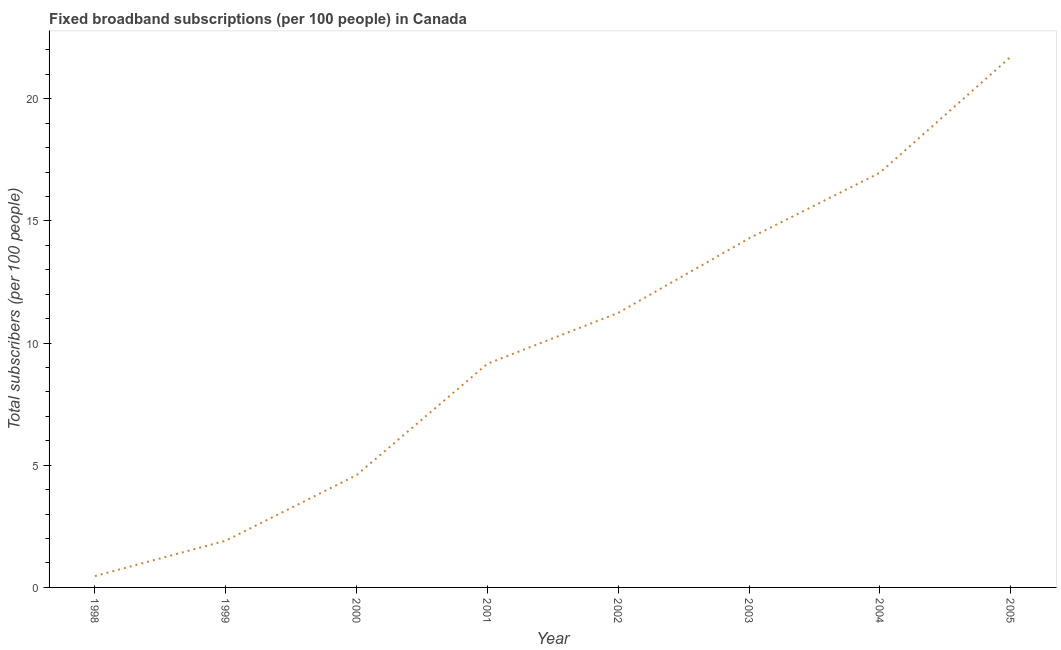What is the total number of fixed broadband subscriptions in 2005?
Offer a terse response. 21.72. Across all years, what is the maximum total number of fixed broadband subscriptions?
Make the answer very short. 21.72. Across all years, what is the minimum total number of fixed broadband subscriptions?
Your answer should be very brief. 0.46. What is the sum of the total number of fixed broadband subscriptions?
Give a very brief answer. 80.33. What is the difference between the total number of fixed broadband subscriptions in 2000 and 2002?
Offer a terse response. -6.64. What is the average total number of fixed broadband subscriptions per year?
Ensure brevity in your answer.  10.04. What is the median total number of fixed broadband subscriptions?
Your response must be concise. 10.19. In how many years, is the total number of fixed broadband subscriptions greater than 3 ?
Provide a short and direct response. 6. Do a majority of the years between 2002 and 2005 (inclusive) have total number of fixed broadband subscriptions greater than 8 ?
Keep it short and to the point. Yes. What is the ratio of the total number of fixed broadband subscriptions in 1998 to that in 2001?
Your answer should be compact. 0.05. Is the total number of fixed broadband subscriptions in 1999 less than that in 2001?
Provide a succinct answer. Yes. What is the difference between the highest and the second highest total number of fixed broadband subscriptions?
Offer a very short reply. 4.75. Is the sum of the total number of fixed broadband subscriptions in 2000 and 2002 greater than the maximum total number of fixed broadband subscriptions across all years?
Your answer should be very brief. No. What is the difference between the highest and the lowest total number of fixed broadband subscriptions?
Ensure brevity in your answer.  21.25. Does the total number of fixed broadband subscriptions monotonically increase over the years?
Provide a succinct answer. Yes. How many lines are there?
Your answer should be compact. 1. How many years are there in the graph?
Offer a terse response. 8. What is the difference between two consecutive major ticks on the Y-axis?
Ensure brevity in your answer.  5. Are the values on the major ticks of Y-axis written in scientific E-notation?
Provide a short and direct response. No. Does the graph contain any zero values?
Keep it short and to the point. No. What is the title of the graph?
Your answer should be very brief. Fixed broadband subscriptions (per 100 people) in Canada. What is the label or title of the X-axis?
Your response must be concise. Year. What is the label or title of the Y-axis?
Make the answer very short. Total subscribers (per 100 people). What is the Total subscribers (per 100 people) of 1998?
Offer a very short reply. 0.46. What is the Total subscribers (per 100 people) of 1999?
Offer a terse response. 1.91. What is the Total subscribers (per 100 people) of 2000?
Ensure brevity in your answer.  4.6. What is the Total subscribers (per 100 people) in 2001?
Give a very brief answer. 9.15. What is the Total subscribers (per 100 people) of 2002?
Offer a very short reply. 11.24. What is the Total subscribers (per 100 people) in 2003?
Your answer should be compact. 14.29. What is the Total subscribers (per 100 people) of 2004?
Make the answer very short. 16.97. What is the Total subscribers (per 100 people) in 2005?
Your response must be concise. 21.72. What is the difference between the Total subscribers (per 100 people) in 1998 and 1999?
Give a very brief answer. -1.45. What is the difference between the Total subscribers (per 100 people) in 1998 and 2000?
Ensure brevity in your answer.  -4.13. What is the difference between the Total subscribers (per 100 people) in 1998 and 2001?
Give a very brief answer. -8.69. What is the difference between the Total subscribers (per 100 people) in 1998 and 2002?
Give a very brief answer. -10.77. What is the difference between the Total subscribers (per 100 people) in 1998 and 2003?
Give a very brief answer. -13.82. What is the difference between the Total subscribers (per 100 people) in 1998 and 2004?
Your answer should be compact. -16.51. What is the difference between the Total subscribers (per 100 people) in 1998 and 2005?
Your response must be concise. -21.25. What is the difference between the Total subscribers (per 100 people) in 1999 and 2000?
Provide a succinct answer. -2.68. What is the difference between the Total subscribers (per 100 people) in 1999 and 2001?
Make the answer very short. -7.24. What is the difference between the Total subscribers (per 100 people) in 1999 and 2002?
Your response must be concise. -9.32. What is the difference between the Total subscribers (per 100 people) in 1999 and 2003?
Offer a terse response. -12.37. What is the difference between the Total subscribers (per 100 people) in 1999 and 2004?
Your answer should be very brief. -15.06. What is the difference between the Total subscribers (per 100 people) in 1999 and 2005?
Offer a very short reply. -19.8. What is the difference between the Total subscribers (per 100 people) in 2000 and 2001?
Give a very brief answer. -4.56. What is the difference between the Total subscribers (per 100 people) in 2000 and 2002?
Offer a very short reply. -6.64. What is the difference between the Total subscribers (per 100 people) in 2000 and 2003?
Offer a very short reply. -9.69. What is the difference between the Total subscribers (per 100 people) in 2000 and 2004?
Your response must be concise. -12.37. What is the difference between the Total subscribers (per 100 people) in 2000 and 2005?
Offer a very short reply. -17.12. What is the difference between the Total subscribers (per 100 people) in 2001 and 2002?
Make the answer very short. -2.08. What is the difference between the Total subscribers (per 100 people) in 2001 and 2003?
Offer a terse response. -5.13. What is the difference between the Total subscribers (per 100 people) in 2001 and 2004?
Give a very brief answer. -7.82. What is the difference between the Total subscribers (per 100 people) in 2001 and 2005?
Offer a terse response. -12.56. What is the difference between the Total subscribers (per 100 people) in 2002 and 2003?
Your response must be concise. -3.05. What is the difference between the Total subscribers (per 100 people) in 2002 and 2004?
Provide a short and direct response. -5.73. What is the difference between the Total subscribers (per 100 people) in 2002 and 2005?
Your response must be concise. -10.48. What is the difference between the Total subscribers (per 100 people) in 2003 and 2004?
Make the answer very short. -2.69. What is the difference between the Total subscribers (per 100 people) in 2003 and 2005?
Provide a succinct answer. -7.43. What is the difference between the Total subscribers (per 100 people) in 2004 and 2005?
Provide a succinct answer. -4.75. What is the ratio of the Total subscribers (per 100 people) in 1998 to that in 1999?
Offer a very short reply. 0.24. What is the ratio of the Total subscribers (per 100 people) in 1998 to that in 2000?
Keep it short and to the point. 0.1. What is the ratio of the Total subscribers (per 100 people) in 1998 to that in 2001?
Provide a succinct answer. 0.05. What is the ratio of the Total subscribers (per 100 people) in 1998 to that in 2002?
Your answer should be very brief. 0.04. What is the ratio of the Total subscribers (per 100 people) in 1998 to that in 2003?
Give a very brief answer. 0.03. What is the ratio of the Total subscribers (per 100 people) in 1998 to that in 2004?
Your response must be concise. 0.03. What is the ratio of the Total subscribers (per 100 people) in 1998 to that in 2005?
Your answer should be very brief. 0.02. What is the ratio of the Total subscribers (per 100 people) in 1999 to that in 2000?
Provide a succinct answer. 0.42. What is the ratio of the Total subscribers (per 100 people) in 1999 to that in 2001?
Make the answer very short. 0.21. What is the ratio of the Total subscribers (per 100 people) in 1999 to that in 2002?
Give a very brief answer. 0.17. What is the ratio of the Total subscribers (per 100 people) in 1999 to that in 2003?
Your answer should be very brief. 0.13. What is the ratio of the Total subscribers (per 100 people) in 1999 to that in 2004?
Provide a short and direct response. 0.11. What is the ratio of the Total subscribers (per 100 people) in 1999 to that in 2005?
Offer a terse response. 0.09. What is the ratio of the Total subscribers (per 100 people) in 2000 to that in 2001?
Offer a very short reply. 0.5. What is the ratio of the Total subscribers (per 100 people) in 2000 to that in 2002?
Provide a succinct answer. 0.41. What is the ratio of the Total subscribers (per 100 people) in 2000 to that in 2003?
Keep it short and to the point. 0.32. What is the ratio of the Total subscribers (per 100 people) in 2000 to that in 2004?
Your response must be concise. 0.27. What is the ratio of the Total subscribers (per 100 people) in 2000 to that in 2005?
Keep it short and to the point. 0.21. What is the ratio of the Total subscribers (per 100 people) in 2001 to that in 2002?
Provide a succinct answer. 0.81. What is the ratio of the Total subscribers (per 100 people) in 2001 to that in 2003?
Ensure brevity in your answer.  0.64. What is the ratio of the Total subscribers (per 100 people) in 2001 to that in 2004?
Provide a short and direct response. 0.54. What is the ratio of the Total subscribers (per 100 people) in 2001 to that in 2005?
Your answer should be very brief. 0.42. What is the ratio of the Total subscribers (per 100 people) in 2002 to that in 2003?
Keep it short and to the point. 0.79. What is the ratio of the Total subscribers (per 100 people) in 2002 to that in 2004?
Ensure brevity in your answer.  0.66. What is the ratio of the Total subscribers (per 100 people) in 2002 to that in 2005?
Your answer should be very brief. 0.52. What is the ratio of the Total subscribers (per 100 people) in 2003 to that in 2004?
Offer a very short reply. 0.84. What is the ratio of the Total subscribers (per 100 people) in 2003 to that in 2005?
Offer a very short reply. 0.66. What is the ratio of the Total subscribers (per 100 people) in 2004 to that in 2005?
Provide a short and direct response. 0.78. 